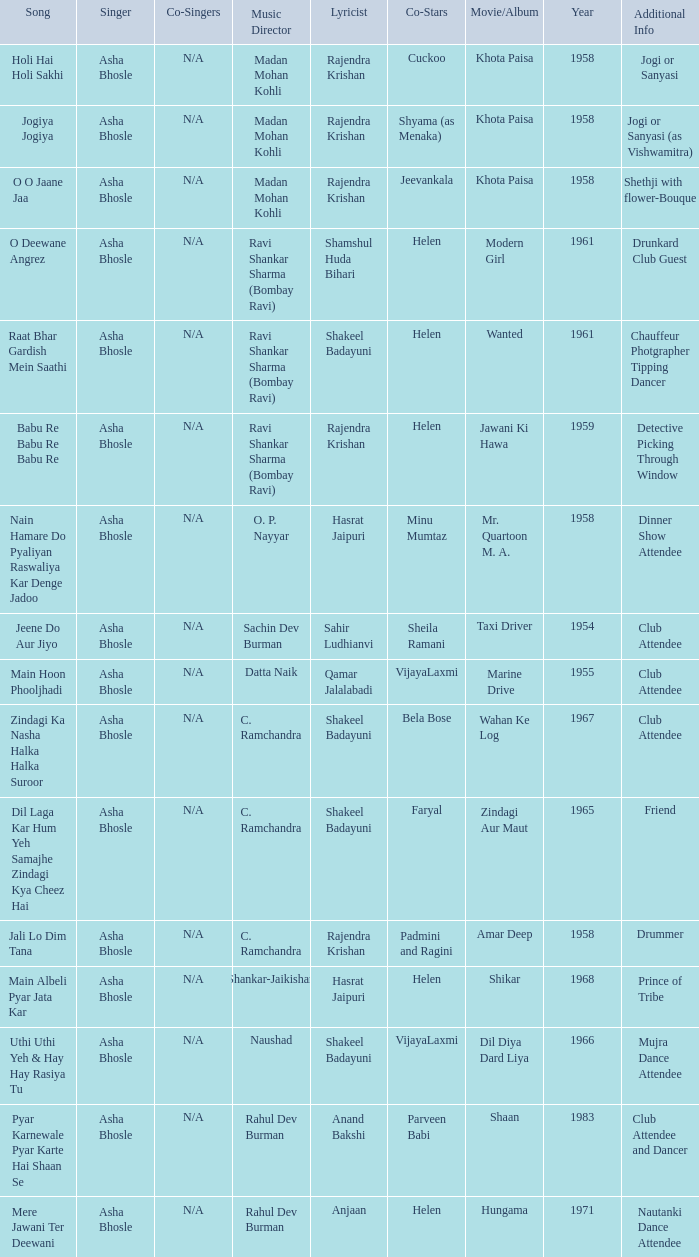What movie did Bela Bose co-star in? Wahan Ke Log. 